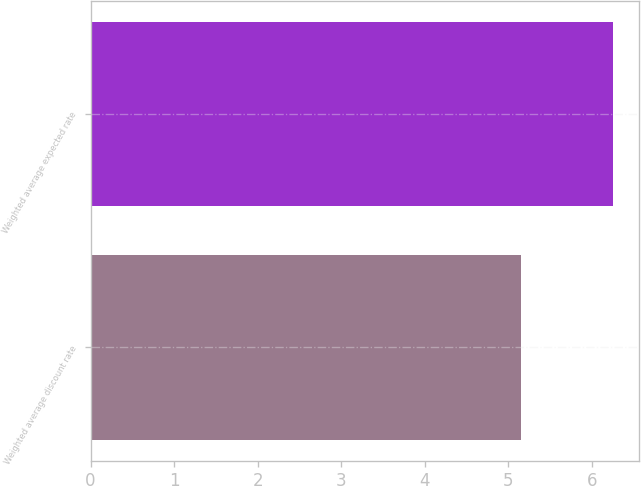Convert chart. <chart><loc_0><loc_0><loc_500><loc_500><bar_chart><fcel>Weighted average discount rate<fcel>Weighted average expected rate<nl><fcel>5.15<fcel>6.25<nl></chart> 